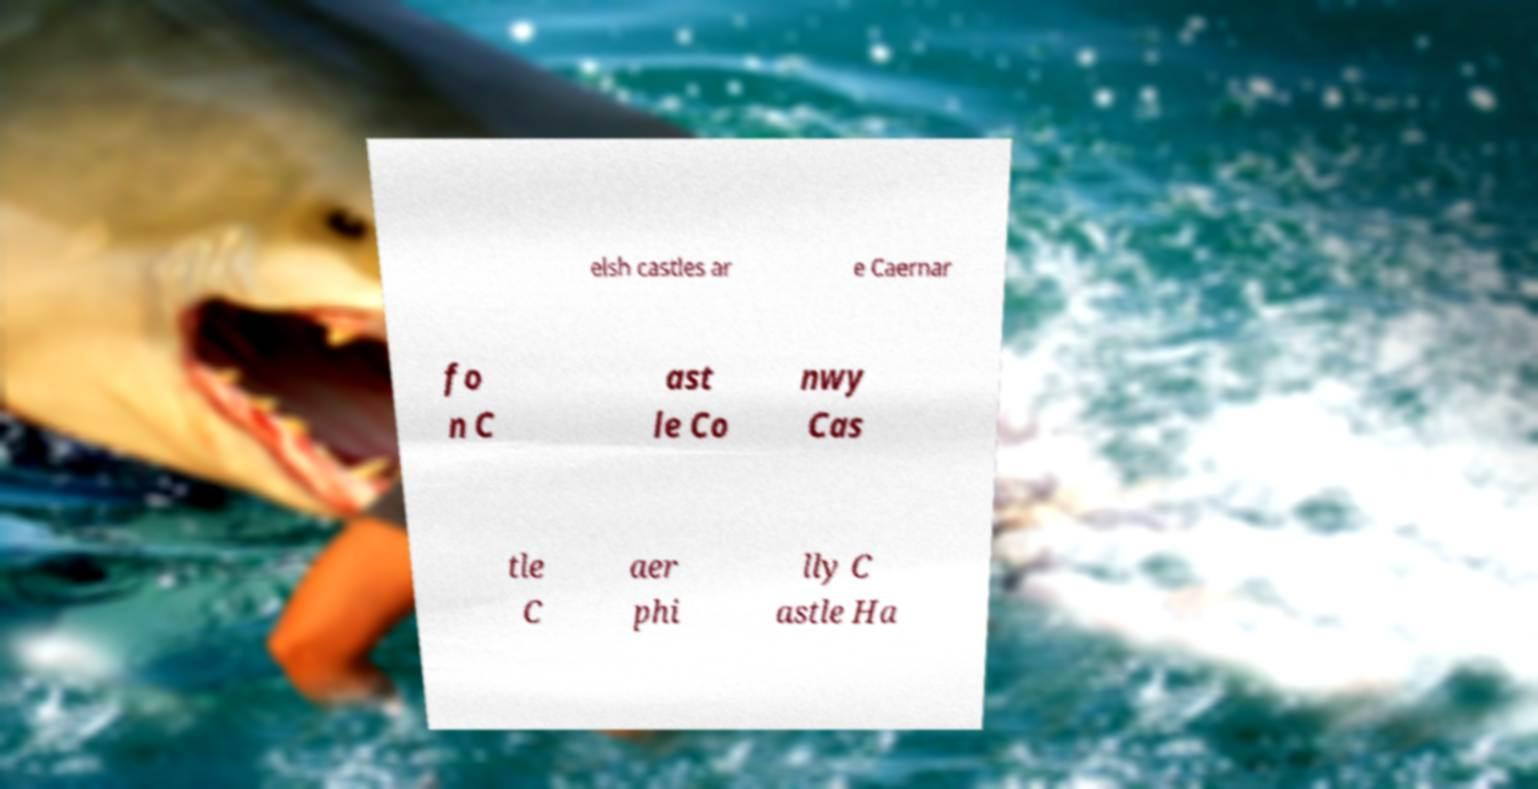Please read and relay the text visible in this image. What does it say? elsh castles ar e Caernar fo n C ast le Co nwy Cas tle C aer phi lly C astle Ha 